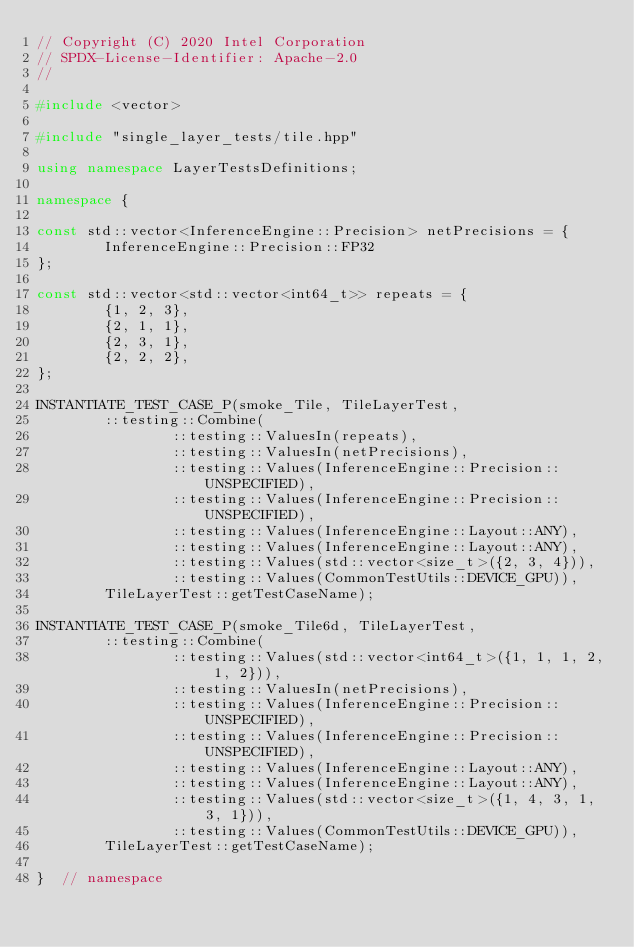Convert code to text. <code><loc_0><loc_0><loc_500><loc_500><_C++_>// Copyright (C) 2020 Intel Corporation
// SPDX-License-Identifier: Apache-2.0
//

#include <vector>

#include "single_layer_tests/tile.hpp"

using namespace LayerTestsDefinitions;

namespace {

const std::vector<InferenceEngine::Precision> netPrecisions = {
        InferenceEngine::Precision::FP32
};

const std::vector<std::vector<int64_t>> repeats = {
        {1, 2, 3},
        {2, 1, 1},
        {2, 3, 1},
        {2, 2, 2},
};

INSTANTIATE_TEST_CASE_P(smoke_Tile, TileLayerTest,
        ::testing::Combine(
                ::testing::ValuesIn(repeats),
                ::testing::ValuesIn(netPrecisions),
                ::testing::Values(InferenceEngine::Precision::UNSPECIFIED),
                ::testing::Values(InferenceEngine::Precision::UNSPECIFIED),
                ::testing::Values(InferenceEngine::Layout::ANY),
                ::testing::Values(InferenceEngine::Layout::ANY),
                ::testing::Values(std::vector<size_t>({2, 3, 4})),
                ::testing::Values(CommonTestUtils::DEVICE_GPU)),
        TileLayerTest::getTestCaseName);

INSTANTIATE_TEST_CASE_P(smoke_Tile6d, TileLayerTest,
        ::testing::Combine(
                ::testing::Values(std::vector<int64_t>({1, 1, 1, 2, 1, 2})),
                ::testing::ValuesIn(netPrecisions),
                ::testing::Values(InferenceEngine::Precision::UNSPECIFIED),
                ::testing::Values(InferenceEngine::Precision::UNSPECIFIED),
                ::testing::Values(InferenceEngine::Layout::ANY),
                ::testing::Values(InferenceEngine::Layout::ANY),
                ::testing::Values(std::vector<size_t>({1, 4, 3, 1, 3, 1})),
                ::testing::Values(CommonTestUtils::DEVICE_GPU)),
        TileLayerTest::getTestCaseName);

}  // namespace
</code> 